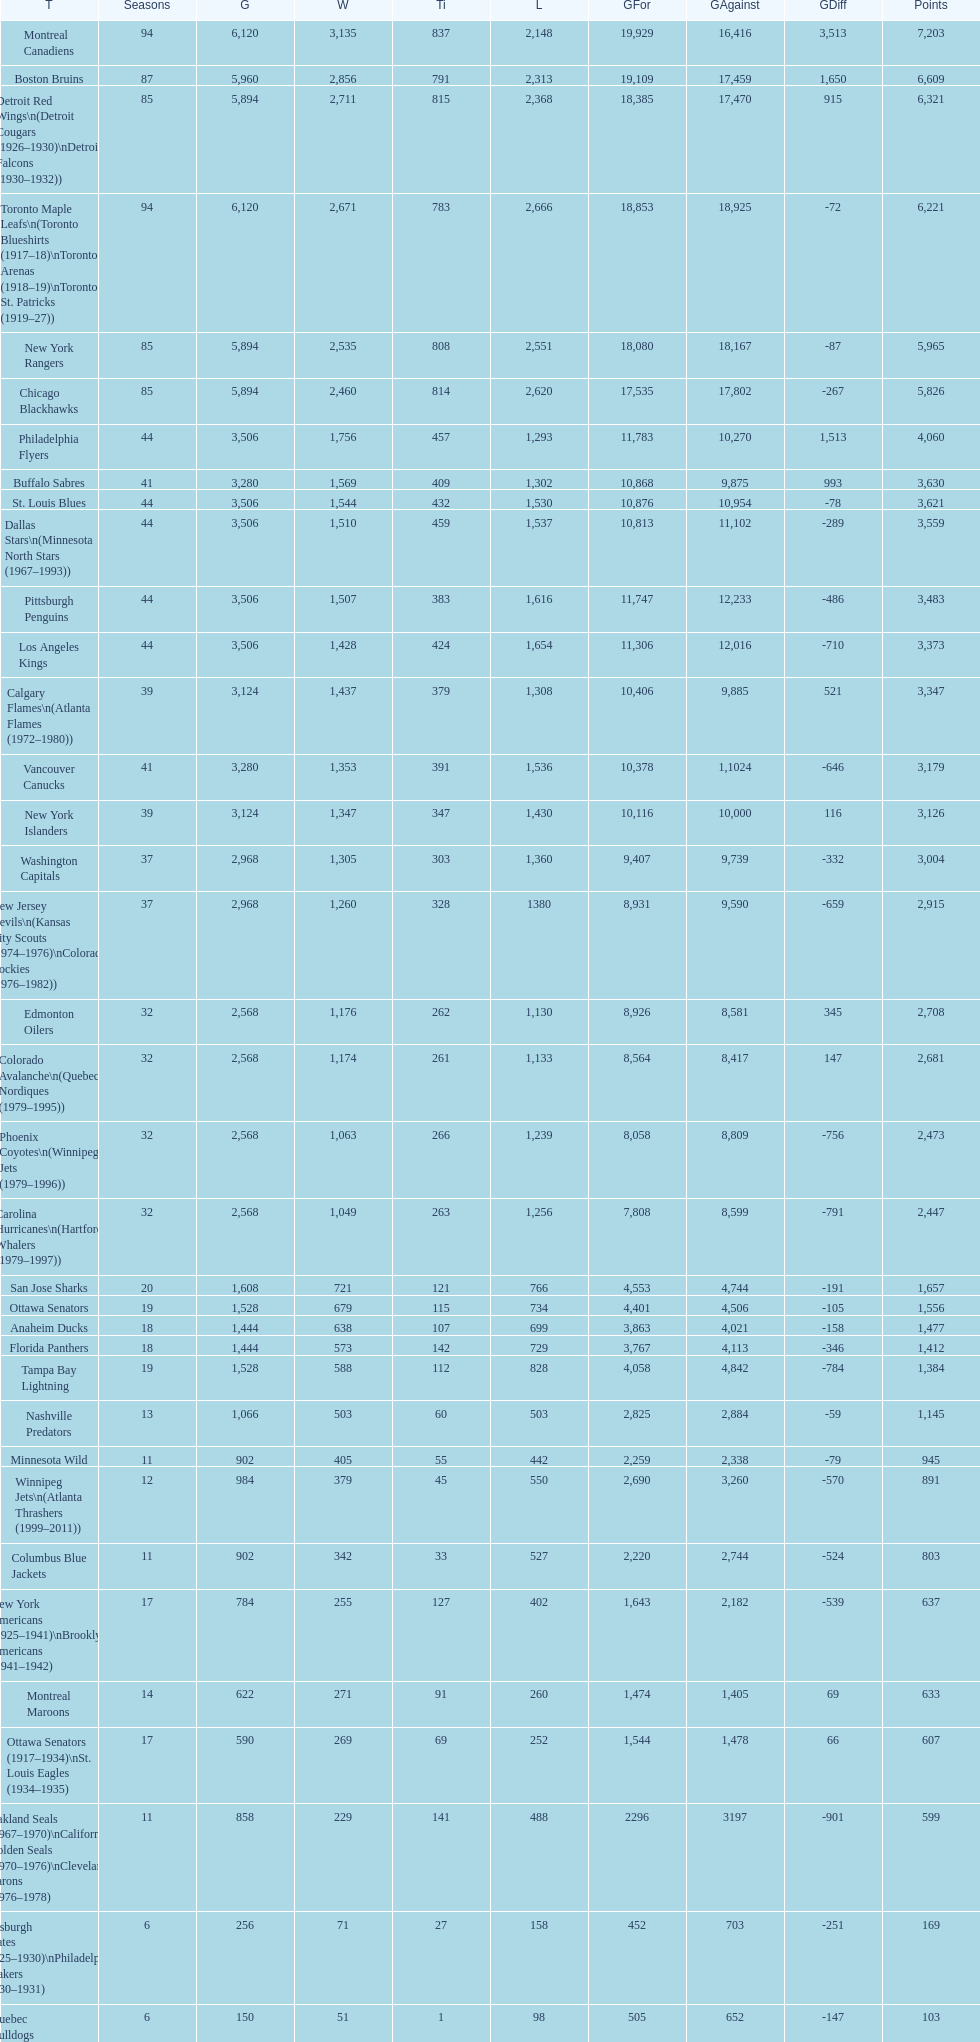What is the number of games that the vancouver canucks have won up to this point? 1,353. 